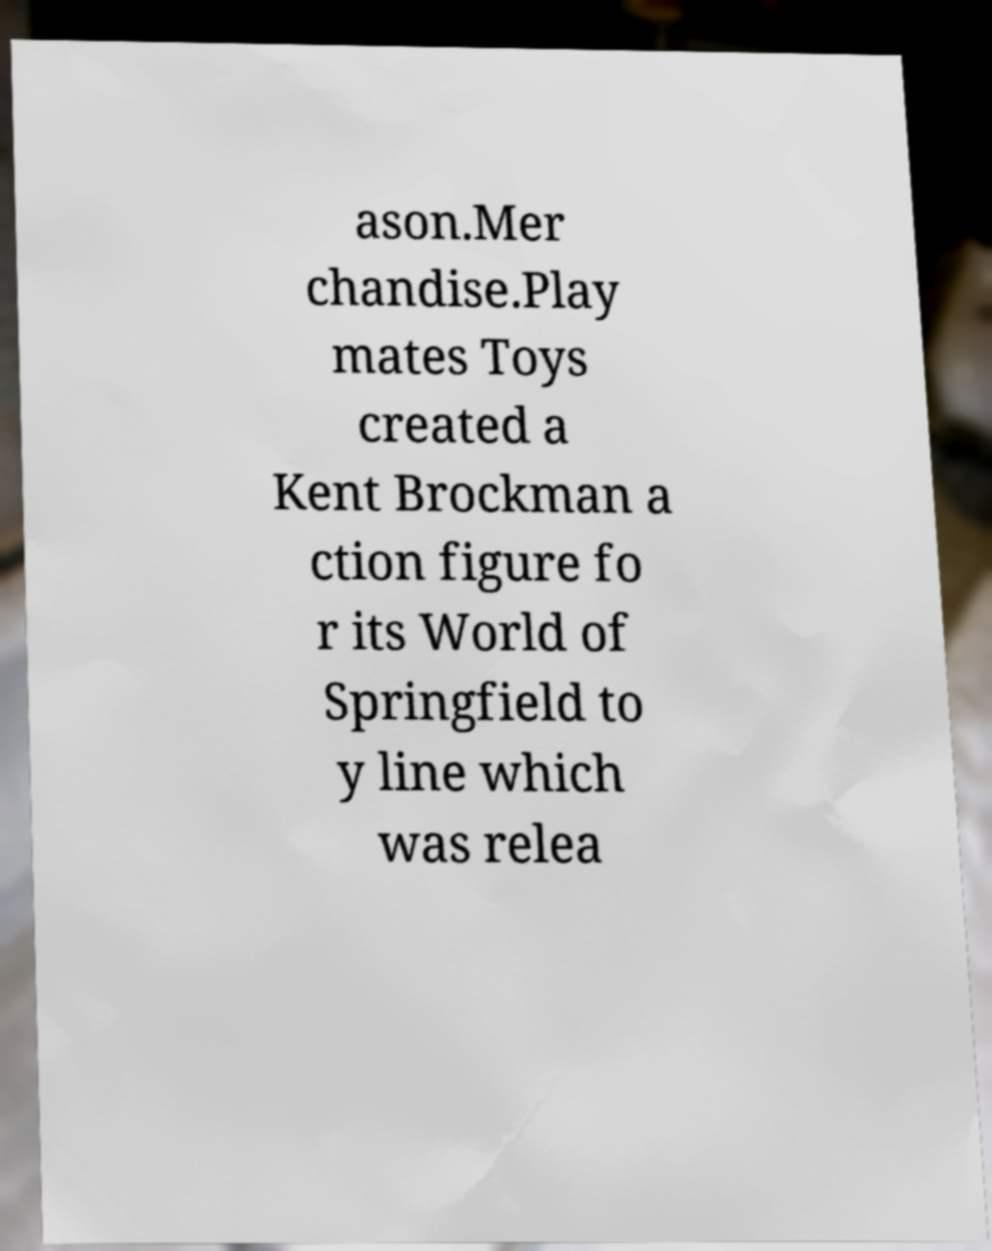Can you read and provide the text displayed in the image?This photo seems to have some interesting text. Can you extract and type it out for me? ason.Mer chandise.Play mates Toys created a Kent Brockman a ction figure fo r its World of Springfield to y line which was relea 